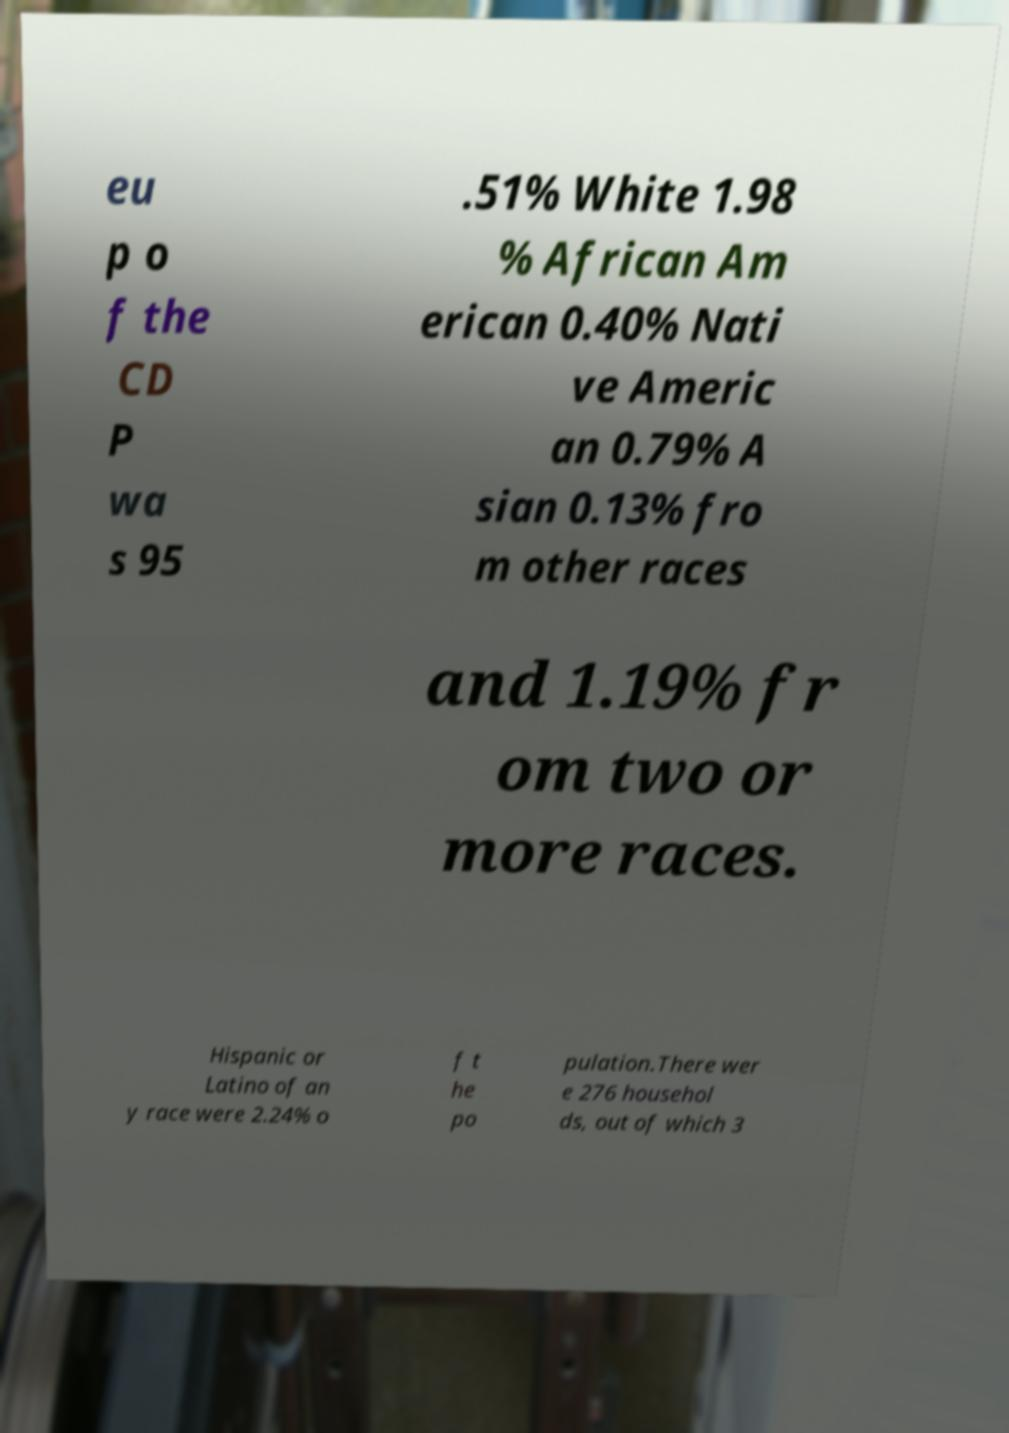Can you read and provide the text displayed in the image?This photo seems to have some interesting text. Can you extract and type it out for me? eu p o f the CD P wa s 95 .51% White 1.98 % African Am erican 0.40% Nati ve Americ an 0.79% A sian 0.13% fro m other races and 1.19% fr om two or more races. Hispanic or Latino of an y race were 2.24% o f t he po pulation.There wer e 276 househol ds, out of which 3 